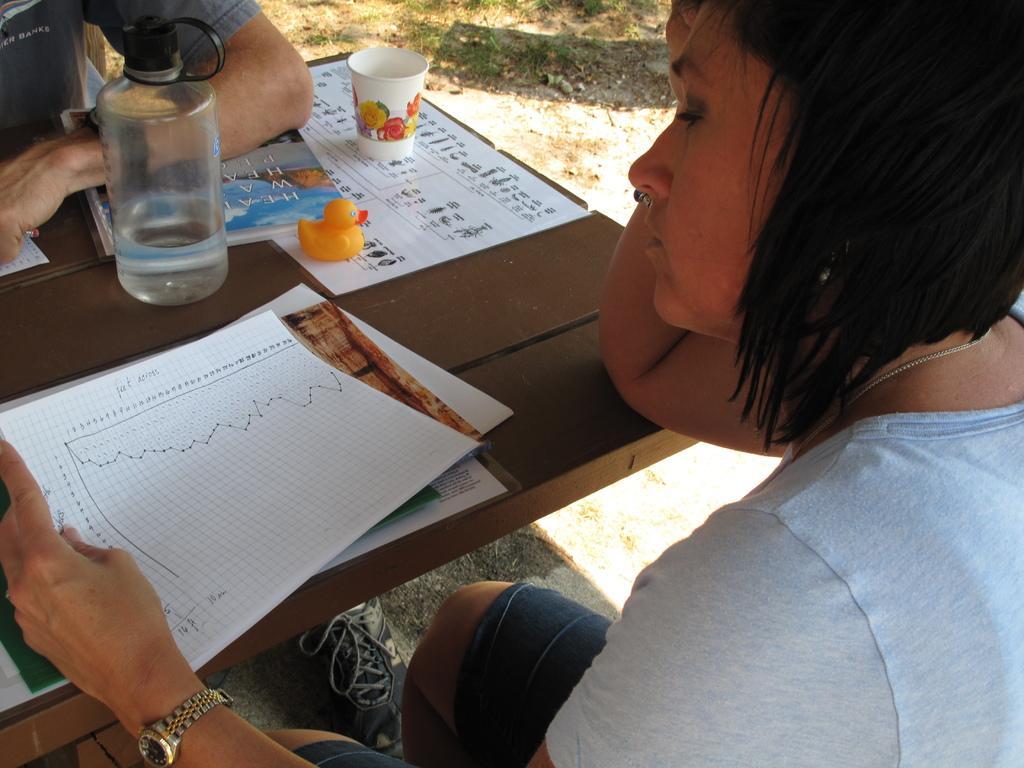Could you give a brief overview of what you see in this image? In the center we can see table,on table we can see papers,glass,toy,book,water bottle,paper cup. And table is surrounded by two persons. 